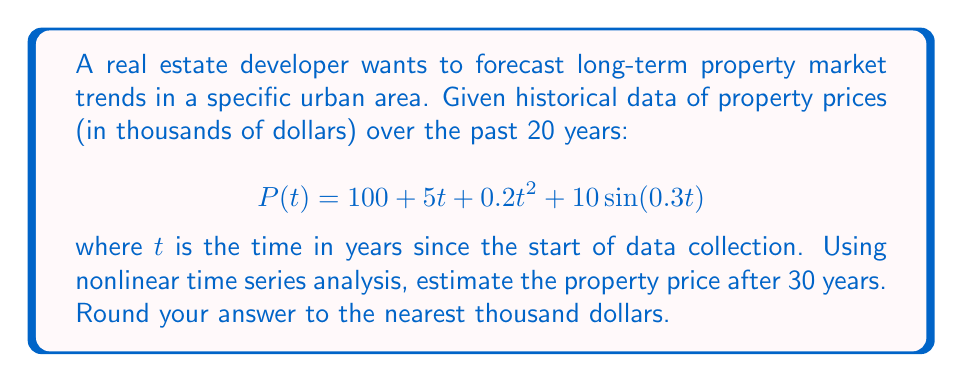Provide a solution to this math problem. To solve this problem, we need to follow these steps:

1) The given equation is a nonlinear time series model:
   $$P(t) = 100 + 5t + 0.2t^2 + 10\sin(0.3t)$$

2) We need to forecast the price at $t = 30$ years:

3) Let's substitute $t = 30$ into the equation:
   $$P(30) = 100 + 5(30) + 0.2(30)^2 + 10\sin(0.3(30))$$

4) Let's calculate each term:
   - $100$ remains $100$
   - $5(30) = 150$
   - $0.2(30)^2 = 0.2(900) = 180$
   - $10\sin(0.3(30)) = 10\sin(9) \approx 4.12$ (using a calculator)

5) Now, let's sum up all terms:
   $$P(30) = 100 + 150 + 180 + 4.12 = 434.12$$

6) The question asks to round to the nearest thousand dollars. 
   434.12 thousand dollars is closest to 434 thousand dollars.

Therefore, the estimated property price after 30 years is 434 thousand dollars.
Answer: $434,000 